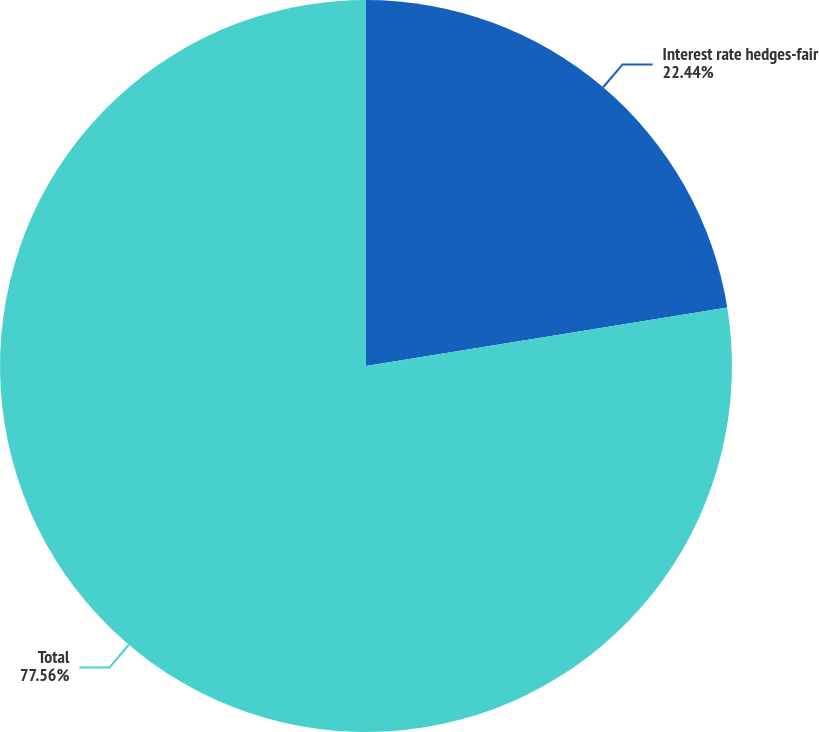Convert chart to OTSL. <chart><loc_0><loc_0><loc_500><loc_500><pie_chart><fcel>Interest rate hedges-fair<fcel>Total<nl><fcel>22.44%<fcel>77.56%<nl></chart> 